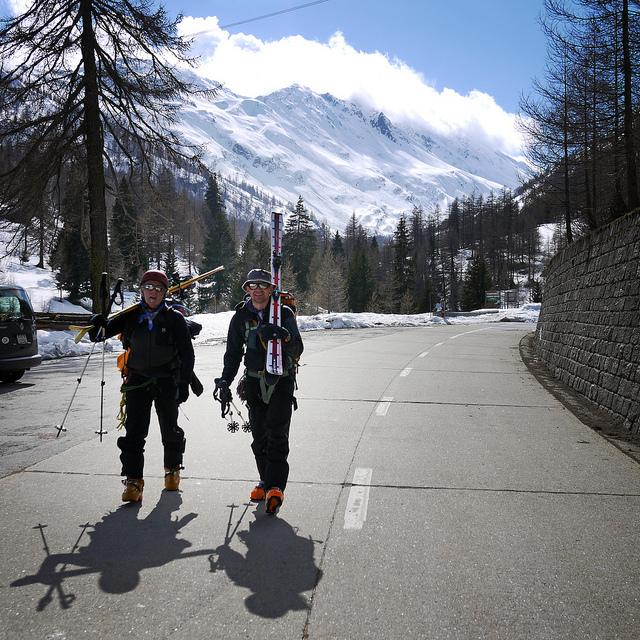The men here prefer to stop at which elevation to start their day of fun? Please explain your reasoning. higher. There is a snowy mountain in the back, and they are dressed warm with their skis in tow. 